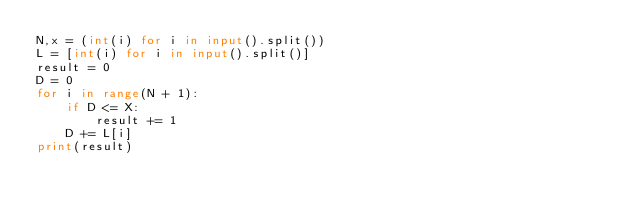<code> <loc_0><loc_0><loc_500><loc_500><_Python_>N,x = (int(i) for i in input().split())
L = [int(i) for i in input().split()] 
result = 0
D = 0
for i in range(N + 1):
    if D <= X:
        result += 1
    D += L[i]
print(result)</code> 